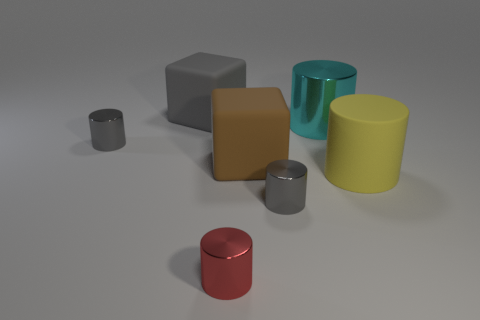What color is the other cylinder that is the same size as the yellow matte cylinder? cyan 